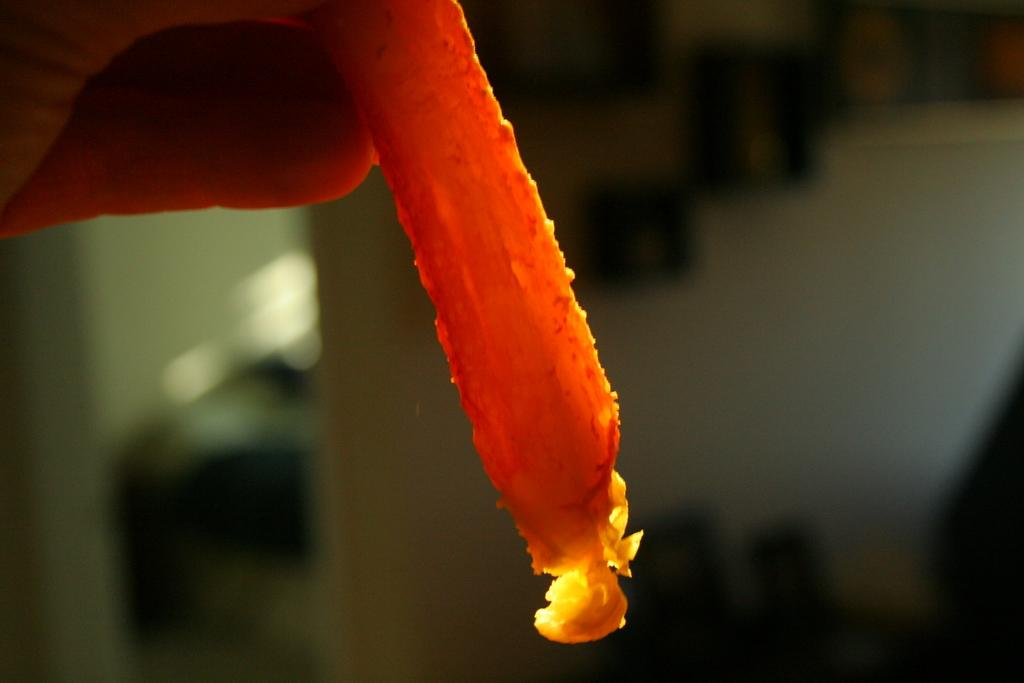What is the main subject of the image? The main subject of the image is a flower petal. Can you describe the background of the image? The background of the image is blurry. Where is the desk located in the image? There is no desk present in the image. How many light bulbs are visible in the image? There are no light bulbs present in the image. 